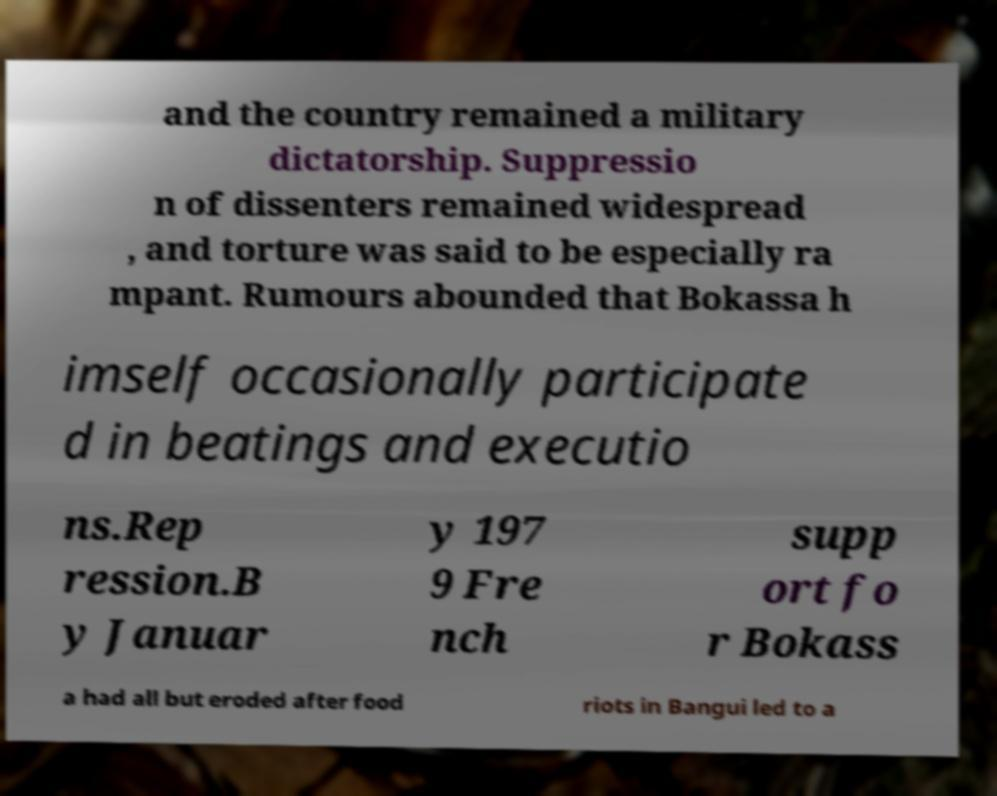I need the written content from this picture converted into text. Can you do that? and the country remained a military dictatorship. Suppressio n of dissenters remained widespread , and torture was said to be especially ra mpant. Rumours abounded that Bokassa h imself occasionally participate d in beatings and executio ns.Rep ression.B y Januar y 197 9 Fre nch supp ort fo r Bokass a had all but eroded after food riots in Bangui led to a 